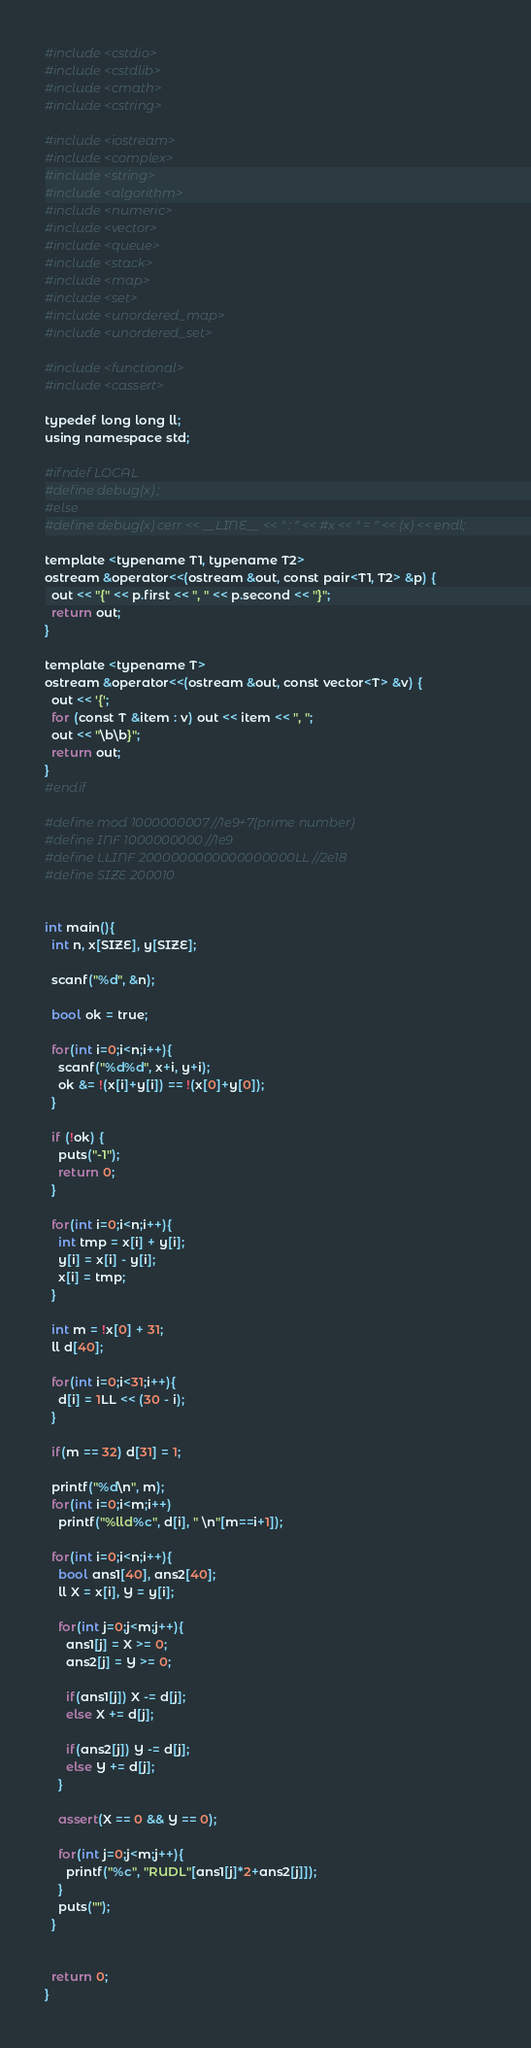<code> <loc_0><loc_0><loc_500><loc_500><_Python_>#include <cstdio>
#include <cstdlib>
#include <cmath>
#include <cstring>

#include <iostream>
#include <complex>
#include <string>
#include <algorithm>
#include <numeric>
#include <vector>
#include <queue>
#include <stack>
#include <map>
#include <set>
#include <unordered_map>
#include <unordered_set>

#include <functional>
#include <cassert>

typedef long long ll;
using namespace std;

#ifndef LOCAL
#define debug(x) ;
#else
#define debug(x) cerr << __LINE__ << " : " << #x << " = " << (x) << endl;

template <typename T1, typename T2>
ostream &operator<<(ostream &out, const pair<T1, T2> &p) {
  out << "{" << p.first << ", " << p.second << "}";
  return out;
}

template <typename T>
ostream &operator<<(ostream &out, const vector<T> &v) {
  out << '{';
  for (const T &item : v) out << item << ", ";
  out << "\b\b}";
  return out;
}
#endif

#define mod 1000000007 //1e9+7(prime number)
#define INF 1000000000 //1e9
#define LLINF 2000000000000000000LL //2e18
#define SIZE 200010


int main(){
  int n, x[SIZE], y[SIZE];

  scanf("%d", &n);

  bool ok = true;

  for(int i=0;i<n;i++){
    scanf("%d%d", x+i, y+i);
    ok &= !(x[i]+y[i]) == !(x[0]+y[0]);
  }

  if (!ok) {
    puts("-1");
    return 0;
  }

  for(int i=0;i<n;i++){
    int tmp = x[i] + y[i];
    y[i] = x[i] - y[i];
    x[i] = tmp;
  }

  int m = !x[0] + 31;
  ll d[40];

  for(int i=0;i<31;i++){
    d[i] = 1LL << (30 - i);
  }

  if(m == 32) d[31] = 1;

  printf("%d\n", m);
  for(int i=0;i<m;i++)
    printf("%lld%c", d[i], " \n"[m==i+1]);

  for(int i=0;i<n;i++){
    bool ans1[40], ans2[40];
    ll X = x[i], Y = y[i];

    for(int j=0;j<m;j++){
      ans1[j] = X >= 0;
      ans2[j] = Y >= 0;

      if(ans1[j]) X -= d[j];
      else X += d[j];

      if(ans2[j]) Y -= d[j];
      else Y += d[j];
    }

    assert(X == 0 && Y == 0);

    for(int j=0;j<m;j++){
      printf("%c", "RUDL"[ans1[j]*2+ans2[j]]);
    }
    puts("");
  }


  return 0;
}
</code> 